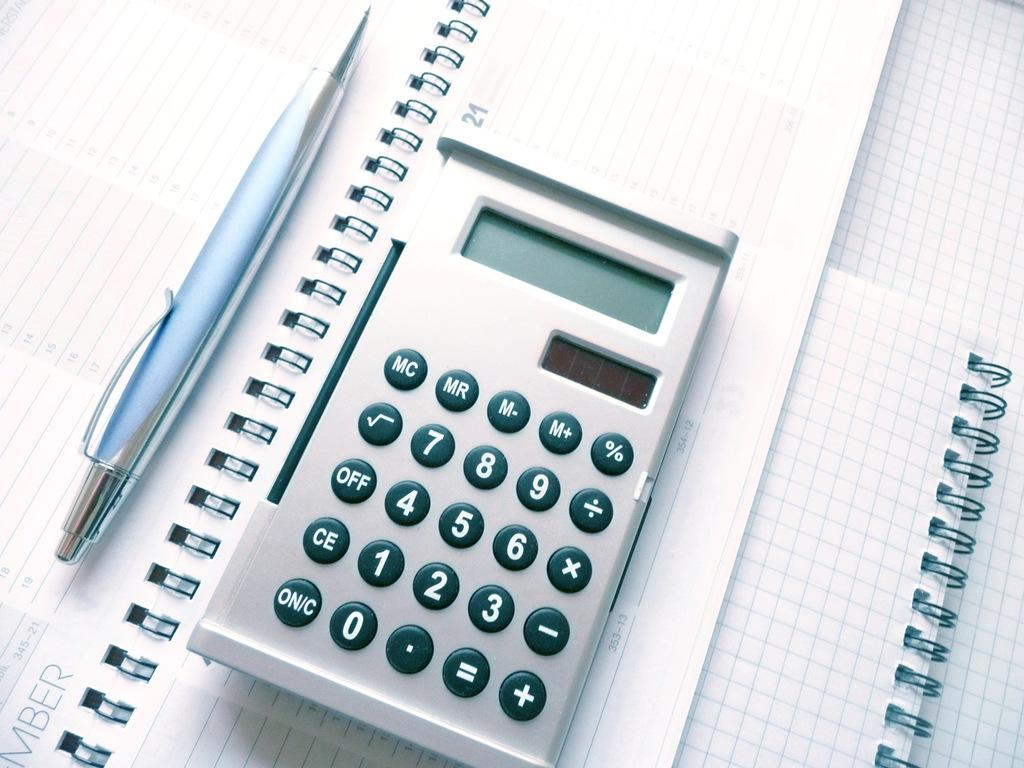What stationery item is visible in the image? There is a pen in the image. What device is also present in the image? There is a calculator in the image. What reading material is visible in the image? There is a book in the image. How many dolls are sitting on the tub in the image? There are no dolls or tub present in the image. Is there a stranger interacting with the pen in the image? There is no stranger present in the image. 